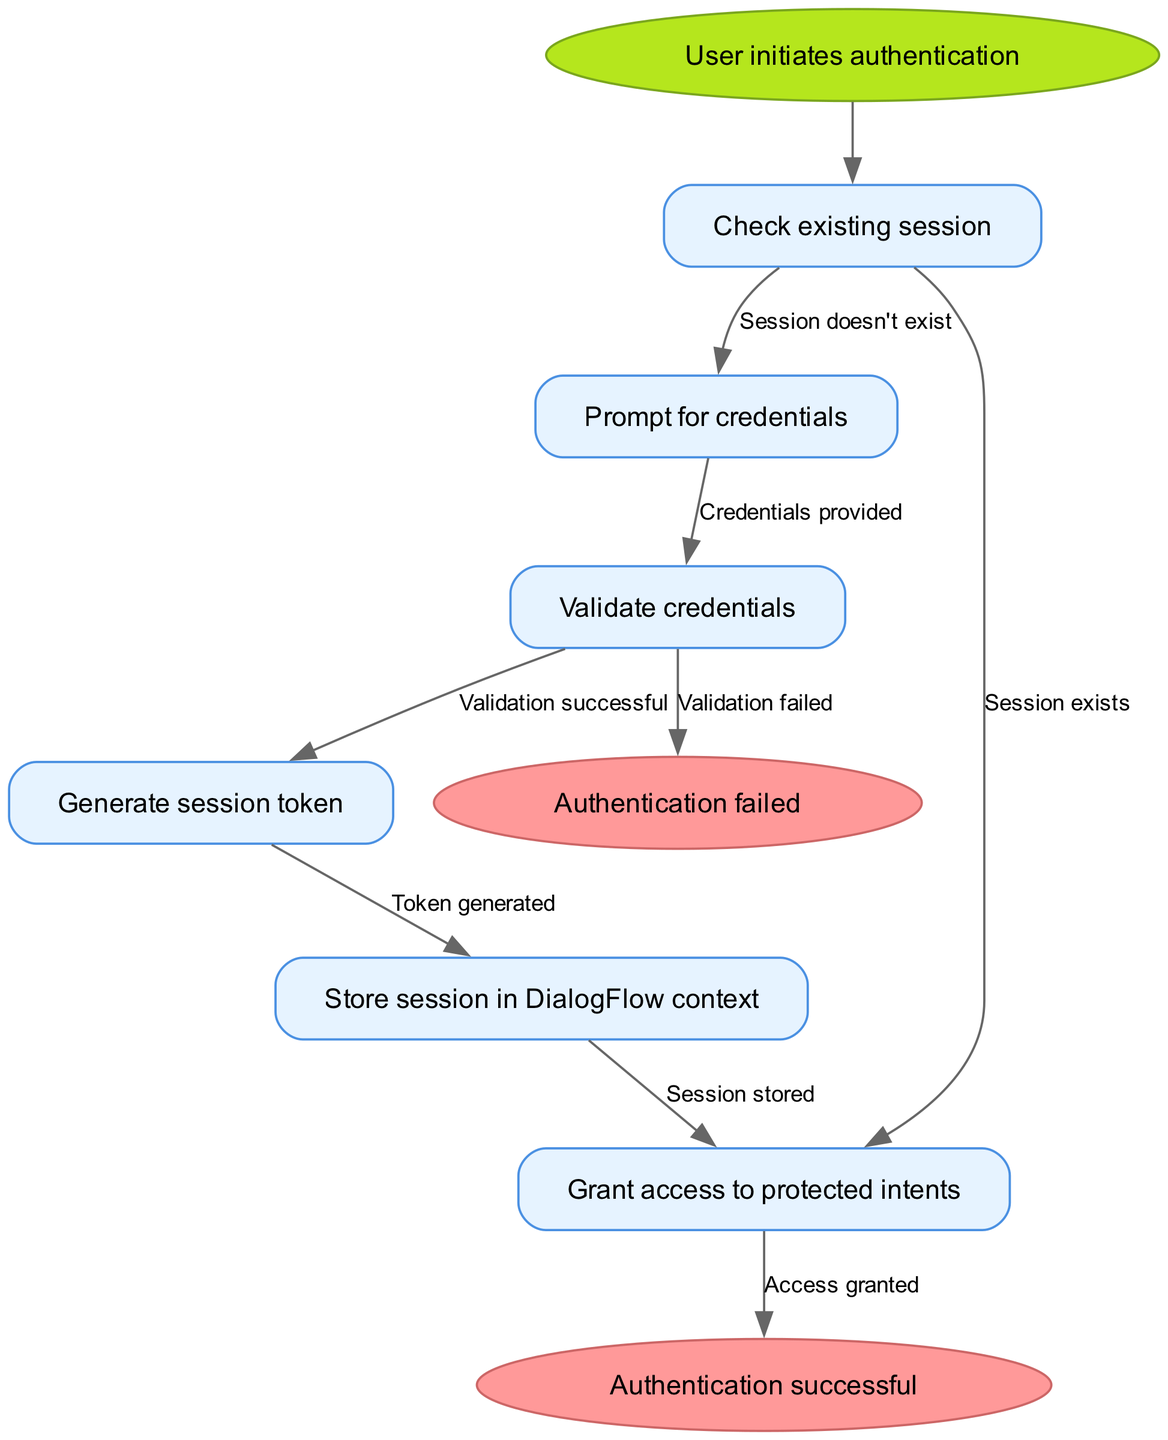What is the starting point of the flowchart? The start node of the flowchart is labeled "User initiates authentication," indicating where the authentication process begins.
Answer: User initiates authentication How many nodes are there in the diagram? The diagram contains six nodes, which are "Check existing session," "Prompt for credentials," "Validate credentials," "Generate session token," "Store session in DialogFlow context," and "Grant access to protected intents."
Answer: Six What node follows the "Validate credentials" node if the validation is successful? If the validation is successful, the next node is "Generate session token," indicating that the process moves forward to token generation.
Answer: Generate session token What happens if a session already exists? If a session exists, the flowchart indicates that access is granted to protected intents, meaning the user is immediately allowed to proceed without entering credentials again.
Answer: Access granted What is the outcome if validation fails? If validation fails, the flowchart leads to the "Authentication failed" node, which signifies that the authentication process could not be completed successfully.
Answer: Authentication failed Which node comes after generating the session token? The node that follows generating the session token is "Store session in DialogFlow context," indicating that the newly created session token needs to be stored for future use.
Answer: Store session in DialogFlow context What edge connects "Check existing session" to "Prompt for credentials"? The edge connecting "Check existing session" to "Prompt for credentials" is labeled "Session doesn't exist," indicating that the user is prompted to provide credentials only if no existing session is detected.
Answer: Session doesn't exist What would be the final outcome if the session is stored successfully? If the session is stored successfully, the final outcome as shown in the flow is "Authentication successful," which indicates that the user has gained access to the system.
Answer: Authentication successful What node indicates failure during the authentication process? The node indicating failure during the authentication process is "Authentication failed," which signifies that the user could not be authenticated.
Answer: Authentication failed If a user provides credentials, which step follows in the process? After the user provides credentials, the following step in the flow is "Validate credentials," which means the provided credentials will be verified against existing records.
Answer: Validate credentials 